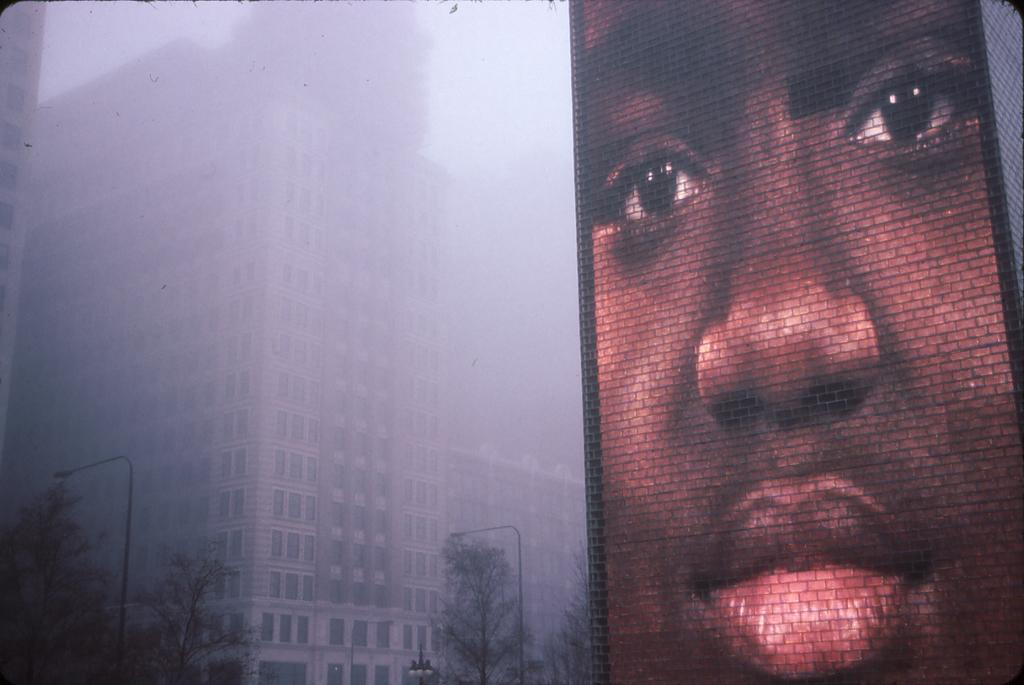What is the main object in the image? There is a screen in the image. What can be seen on the screen? The screen displays buildings, trees, and electric poles with lights. What is visible in the background of the image? The sky is visible in the background of the image. Where is the playground located in the image? There is no playground present in the image. What type of whip is being used by the person on the screen? There are no people or whips visible on the screen; it displays buildings, trees, and electric poles with lights. 